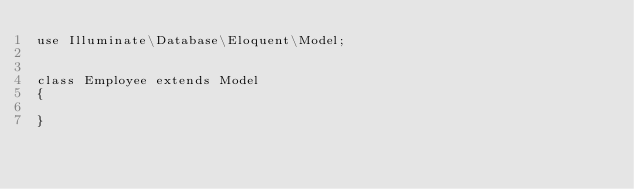Convert code to text. <code><loc_0><loc_0><loc_500><loc_500><_PHP_>use Illuminate\Database\Eloquent\Model;


class Employee extends Model
{
    
}
</code> 